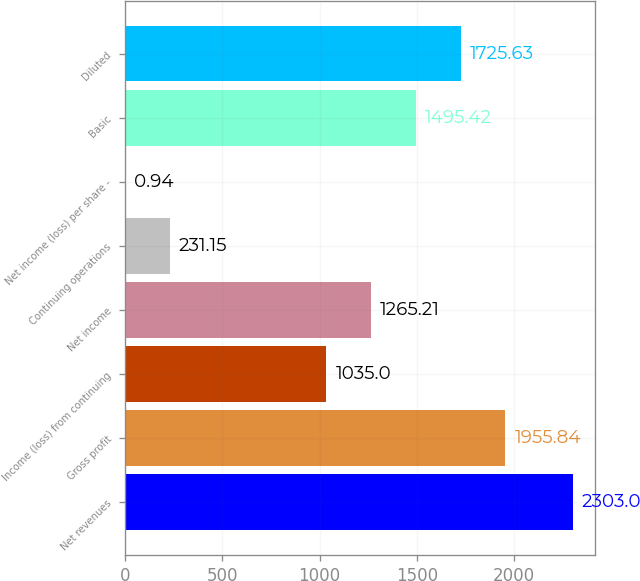<chart> <loc_0><loc_0><loc_500><loc_500><bar_chart><fcel>Net revenues<fcel>Gross profit<fcel>Income (loss) from continuing<fcel>Net income<fcel>Continuing operations<fcel>Net income (loss) per share -<fcel>Basic<fcel>Diluted<nl><fcel>2303<fcel>1955.84<fcel>1035<fcel>1265.21<fcel>231.15<fcel>0.94<fcel>1495.42<fcel>1725.63<nl></chart> 